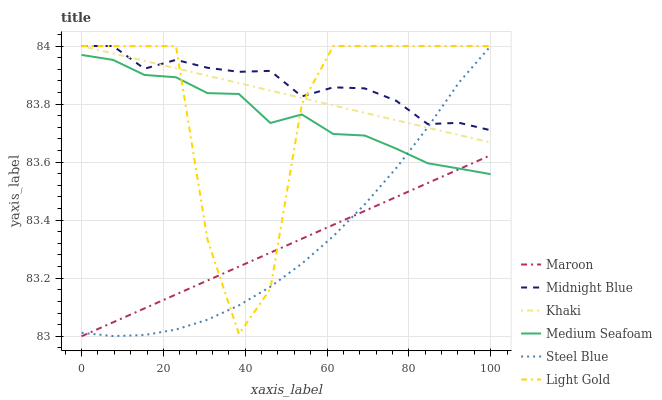Does Maroon have the minimum area under the curve?
Answer yes or no. Yes. Does Midnight Blue have the maximum area under the curve?
Answer yes or no. Yes. Does Steel Blue have the minimum area under the curve?
Answer yes or no. No. Does Steel Blue have the maximum area under the curve?
Answer yes or no. No. Is Khaki the smoothest?
Answer yes or no. Yes. Is Light Gold the roughest?
Answer yes or no. Yes. Is Midnight Blue the smoothest?
Answer yes or no. No. Is Midnight Blue the roughest?
Answer yes or no. No. Does Steel Blue have the lowest value?
Answer yes or no. No. Does Maroon have the highest value?
Answer yes or no. No. Is Medium Seafoam less than Khaki?
Answer yes or no. Yes. Is Midnight Blue greater than Maroon?
Answer yes or no. Yes. Does Medium Seafoam intersect Khaki?
Answer yes or no. No. 